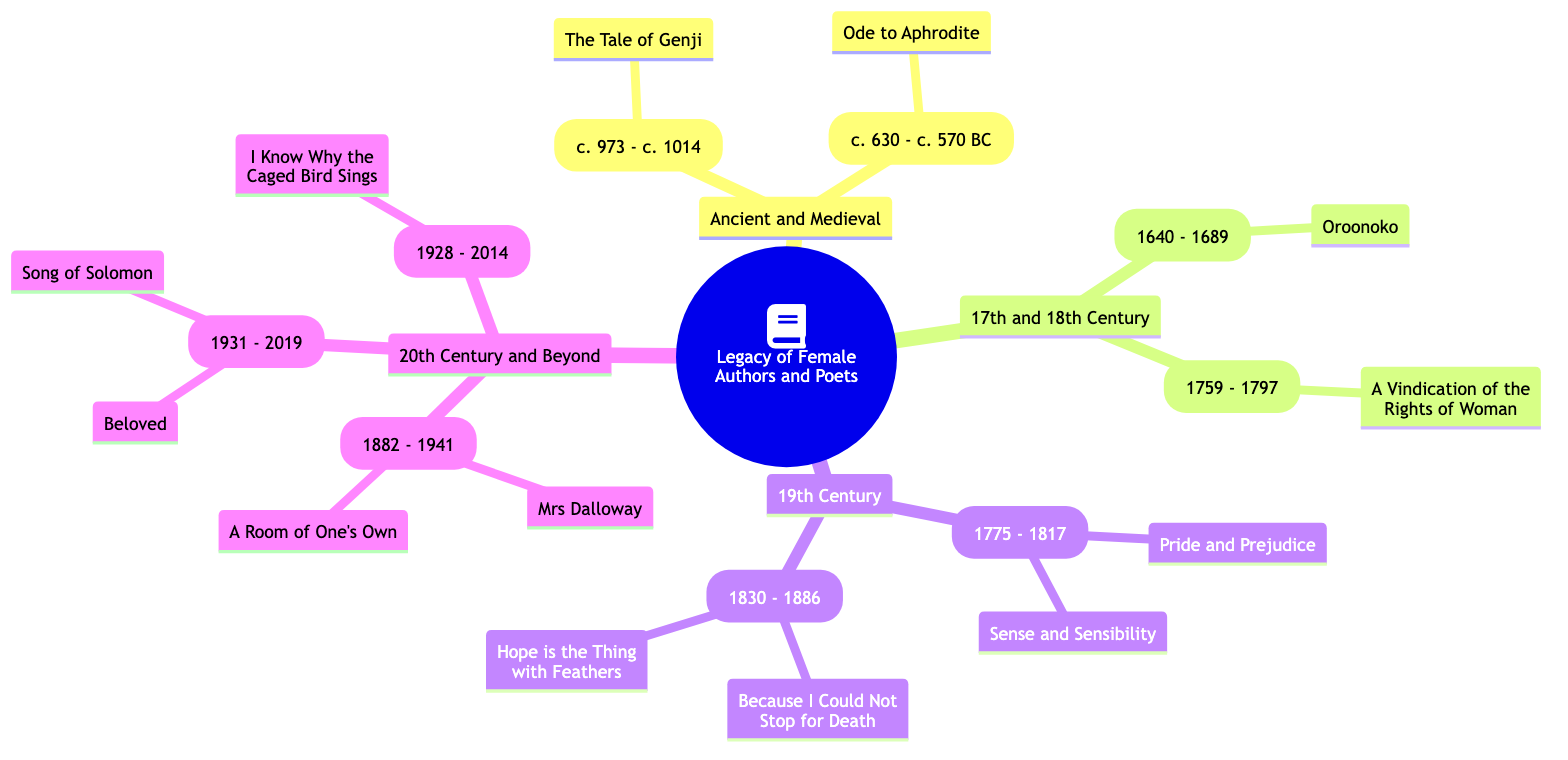What notable work is associated with Sappho? The diagram indicates that Sappho is associated with the notable work "Ode to Aphrodite." This information is directly listed under her name in the "Ancient and Medieval" section.
Answer: Ode to Aphrodite Who wrote "A Vindication of the Rights of Woman"? The diagram shows that Mary Wollstonecraft is the author of "A Vindication of the Rights of Woman." This is explicitly mentioned next to her name in the "17th and 18th Century" section.
Answer: Mary Wollstonecraft How many authors are listed in the "20th Century and Beyond" section? Upon reviewing the diagram, there are three authors mentioned in the "20th Century and Beyond" section: Virginia Woolf, Toni Morrison, and Maya Angelou. Counting these entries gives a total of three.
Answer: 3 Which author wrote "Pride and Prejudice"? The diagram specifies that Jane Austen is the author of "Pride and Prejudice." Her name appears under the "19th Century" section alongside this notable work.
Answer: Jane Austen What impact did Murasaki Shikibu have on literature? The diagram states that Murasaki Shikibu had an impact by authoring the world's first novel, which influenced Japanese literature and culture. This information can be found directly below her name.
Answer: Authoring the world's first novel Which two authors are associated with the 19th Century? The diagram lists Jane Austen and Emily Dickinson under the "19th Century" section. The names are clearly separated in this section, showing that both authors belonged to this period.
Answer: Jane Austen, Emily Dickinson What is the societal impact of Maya Angelou's writing? The diagram indicates that Maya Angelou's writings articulate the power of literature in overcoming racism and trauma, inspiring generations. This impact is detailed in the "20th Century and Beyond" section next to her name.
Answer: Power of literature in overcoming racism and trauma What genre did Virginia Woolf contribute to? According to the diagram, Virginia Woolf is known for innovating the modernist literary movement as indicated in her impact statement found in the "20th Century and Beyond" section.
Answer: Modernist literary movement Who is recognized as one of the first English women to earn a living by writing? The diagram identifies Aphra Behn as one of the first English women who broke barriers for women in literature by earning a living through her writing. This is attributed to her in the "17th and 18th Century" section.
Answer: Aphra Behn 